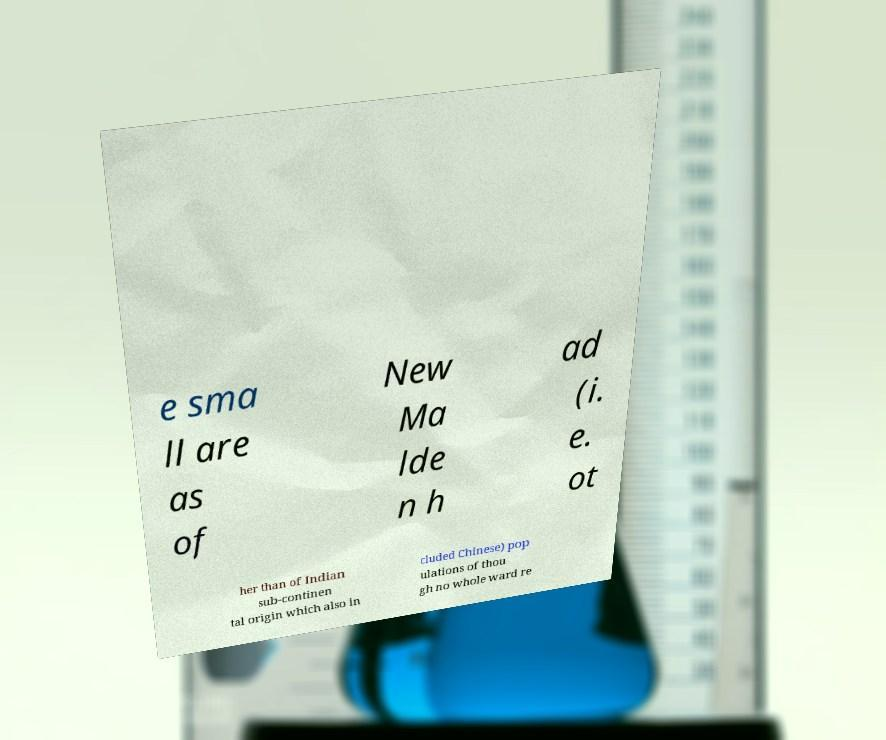I need the written content from this picture converted into text. Can you do that? e sma ll are as of New Ma lde n h ad (i. e. ot her than of Indian sub-continen tal origin which also in cluded Chinese) pop ulations of thou gh no whole ward re 